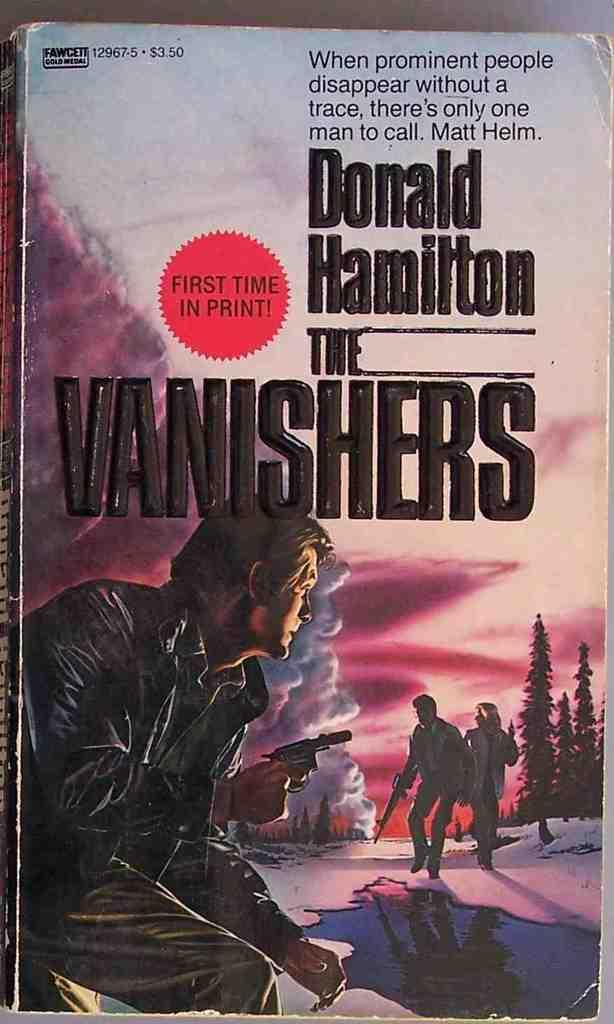<image>
Give a short and clear explanation of the subsequent image. A book by Donald Hamilton has a man with a gun on the cover. 